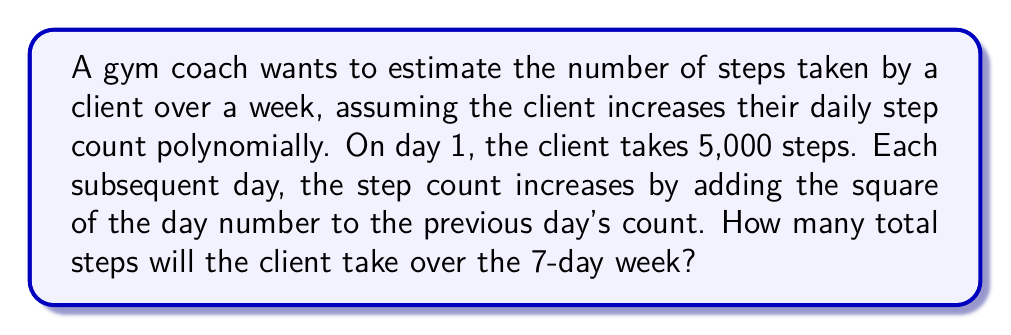What is the answer to this math problem? Let's approach this step-by-step:

1) First, let's write out the polynomial function for the daily step count:
   $$S(n) = 5000 + \sum_{i=1}^{n-1} i^2$$
   where $S(n)$ is the step count on day $n$.

2) Let's calculate the step count for each day:
   Day 1: $S(1) = 5000$
   Day 2: $S(2) = 5000 + 1^2 = 5001$
   Day 3: $S(3) = 5001 + 2^2 = 5005$
   Day 4: $S(4) = 5005 + 3^2 = 5014$
   Day 5: $S(5) = 5014 + 4^2 = 5030$
   Day 6: $S(6) = 5030 + 5^2 = 5055$
   Day 7: $S(7) = 5055 + 6^2 = 5091$

3) To find the total steps over the week, we need to sum these daily counts:
   $$\text{Total Steps} = \sum_{n=1}^7 S(n)$$

4) Summing up:
   $$\text{Total Steps} = 5000 + 5001 + 5005 + 5014 + 5030 + 5055 + 5091 = 35,196$$

Therefore, the client will take a total of 35,196 steps over the 7-day week.
Answer: 35,196 steps 